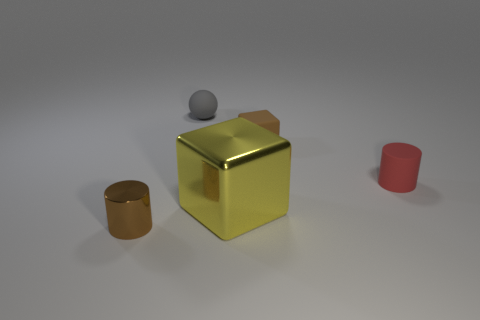Subtract all brown blocks. How many blocks are left? 1 Subtract 1 blocks. How many blocks are left? 1 Subtract all blocks. How many objects are left? 3 Subtract all purple balls. Subtract all yellow cylinders. How many balls are left? 1 Subtract all blue balls. How many yellow blocks are left? 1 Subtract all small rubber balls. Subtract all tiny rubber cylinders. How many objects are left? 3 Add 5 tiny red matte objects. How many tiny red matte objects are left? 6 Add 3 small gray rubber objects. How many small gray rubber objects exist? 4 Add 3 tiny cylinders. How many objects exist? 8 Subtract 1 brown cylinders. How many objects are left? 4 